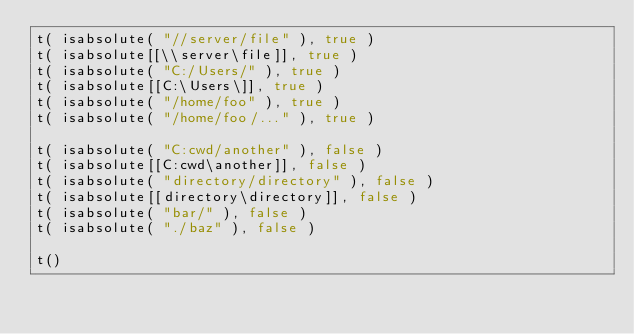Convert code to text. <code><loc_0><loc_0><loc_500><loc_500><_Lua_>t( isabsolute( "//server/file" ), true )
t( isabsolute[[\\server\file]], true )
t( isabsolute( "C:/Users/" ), true )
t( isabsolute[[C:\Users\]], true )
t( isabsolute( "/home/foo" ), true )
t( isabsolute( "/home/foo/..." ), true )

t( isabsolute( "C:cwd/another" ), false )
t( isabsolute[[C:cwd\another]], false )
t( isabsolute( "directory/directory" ), false )
t( isabsolute[[directory\directory]], false )
t( isabsolute( "bar/" ), false )
t( isabsolute( "./baz" ), false )

t()
</code> 